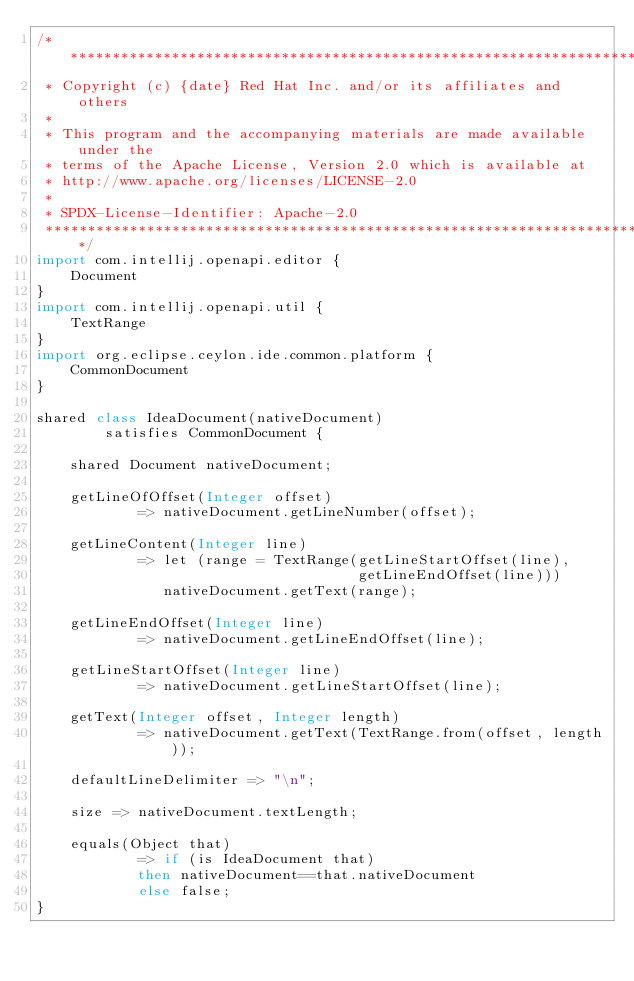<code> <loc_0><loc_0><loc_500><loc_500><_Ceylon_>/********************************************************************************
 * Copyright (c) {date} Red Hat Inc. and/or its affiliates and others
 *
 * This program and the accompanying materials are made available under the 
 * terms of the Apache License, Version 2.0 which is available at
 * http://www.apache.org/licenses/LICENSE-2.0
 *
 * SPDX-License-Identifier: Apache-2.0 
 ********************************************************************************/
import com.intellij.openapi.editor {
    Document
}
import com.intellij.openapi.util {
    TextRange
}
import org.eclipse.ceylon.ide.common.platform {
    CommonDocument
}

shared class IdeaDocument(nativeDocument)
        satisfies CommonDocument {

    shared Document nativeDocument;
    
    getLineOfOffset(Integer offset) 
            => nativeDocument.getLineNumber(offset);

    getLineContent(Integer line)
            => let (range = TextRange(getLineStartOffset(line), 
                                      getLineEndOffset(line)))
               nativeDocument.getText(range);

    getLineEndOffset(Integer line) 
            => nativeDocument.getLineEndOffset(line);

    getLineStartOffset(Integer line) 
            => nativeDocument.getLineStartOffset(line);

    getText(Integer offset, Integer length)
            => nativeDocument.getText(TextRange.from(offset, length));

    defaultLineDelimiter => "\n";

    size => nativeDocument.textLength;

    equals(Object that) 
            => if (is IdeaDocument that) 
            then nativeDocument==that.nativeDocument 
            else false;
}
</code> 